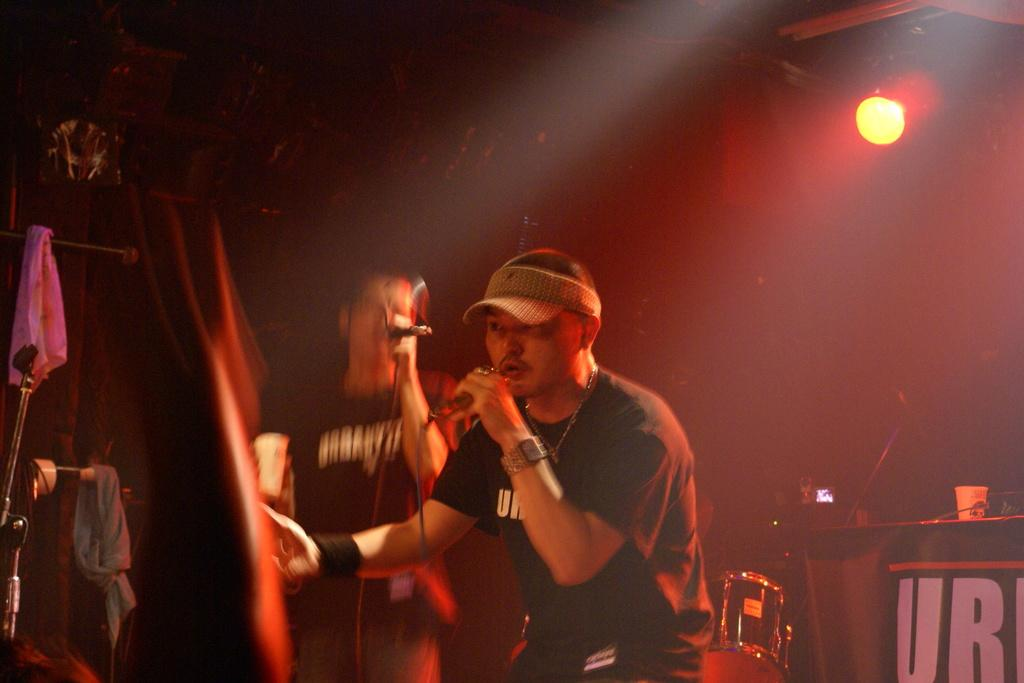How many people are on the stage in the image? There are two men standing on the stage in the image. What are the men doing on the stage? The men are singing on microphones. What can be seen in the background of the stage? There are musical instruments and lights visible in the background. Can you tell me how many fish are swimming in the background of the image? There are no fish present in the image; it features two men singing on stage with musical instruments and lights in the background. 